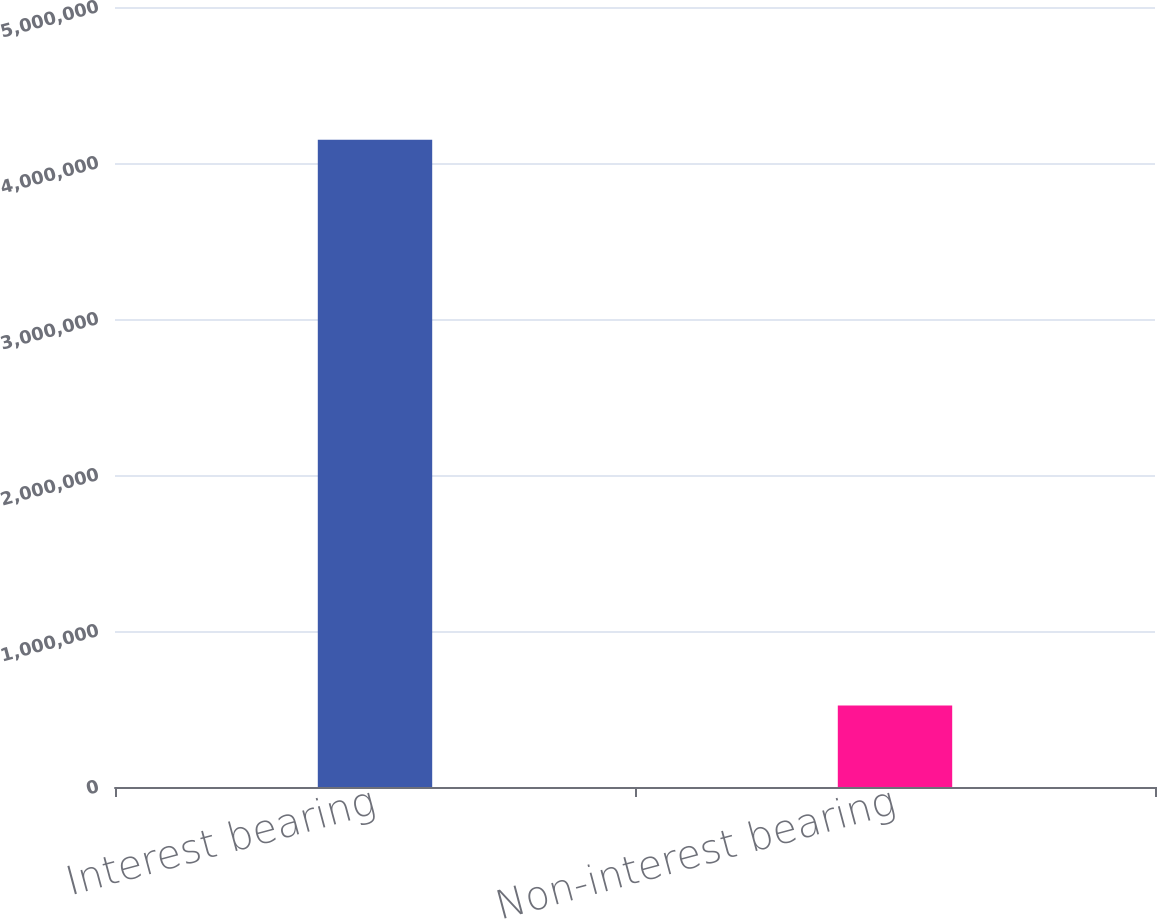Convert chart to OTSL. <chart><loc_0><loc_0><loc_500><loc_500><bar_chart><fcel>Interest bearing<fcel>Non-interest bearing<nl><fcel>4.14895e+06<fcel>522121<nl></chart> 